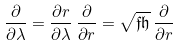Convert formula to latex. <formula><loc_0><loc_0><loc_500><loc_500>\frac { \partial } { \partial \lambda } = \frac { \partial r } { \partial \lambda } \, \frac { \partial } { \partial r } = \sqrt { \mathfrak f \mathfrak h } \, \frac { \partial } { \partial r }</formula> 